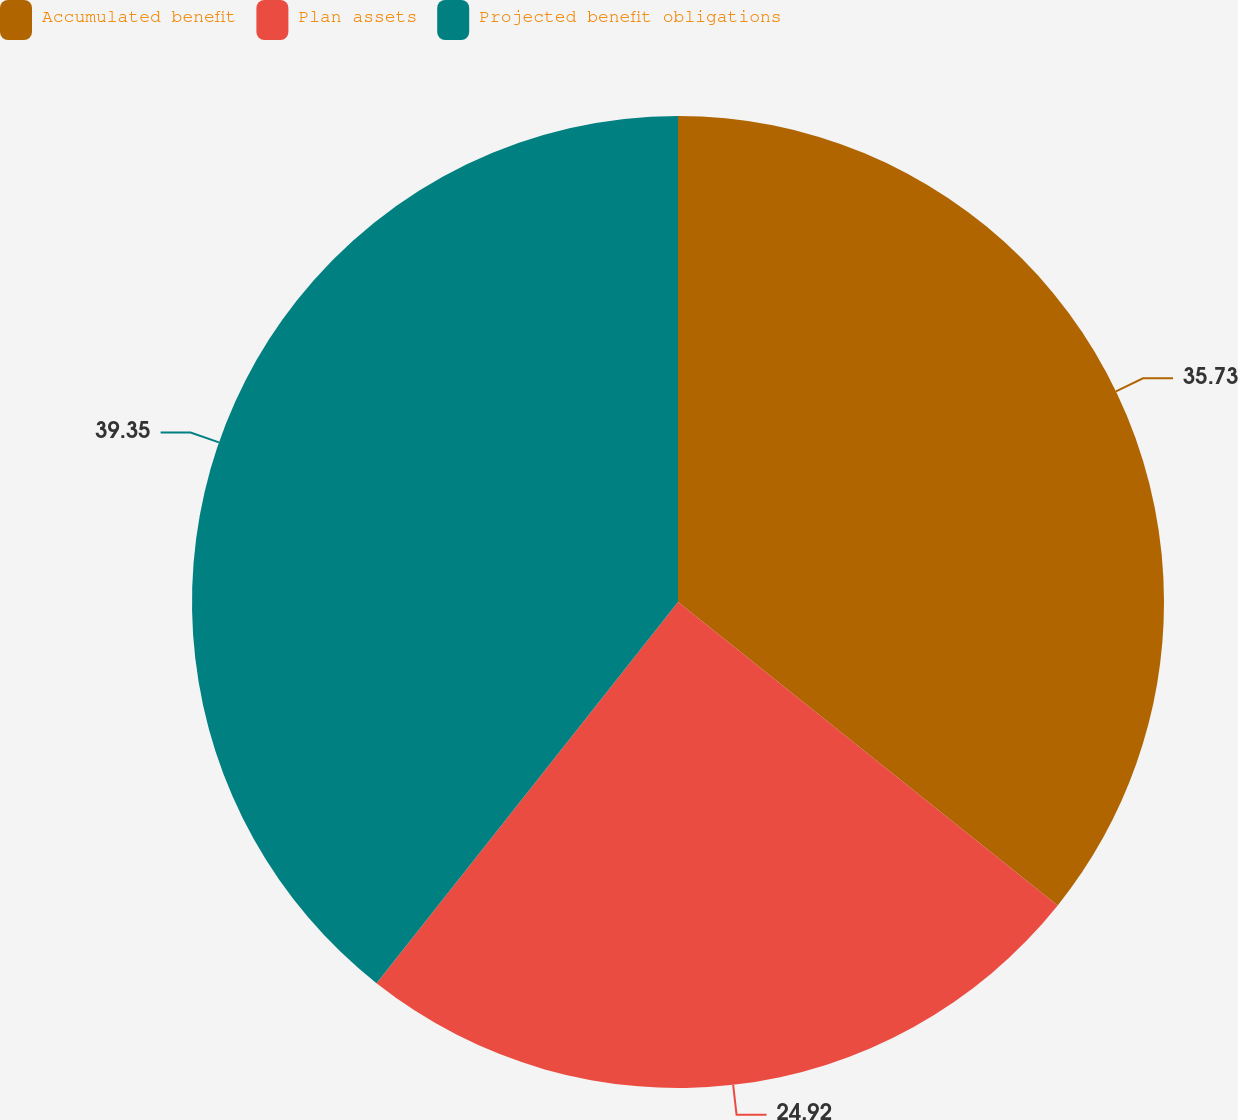Convert chart. <chart><loc_0><loc_0><loc_500><loc_500><pie_chart><fcel>Accumulated benefit<fcel>Plan assets<fcel>Projected benefit obligations<nl><fcel>35.73%<fcel>24.92%<fcel>39.35%<nl></chart> 